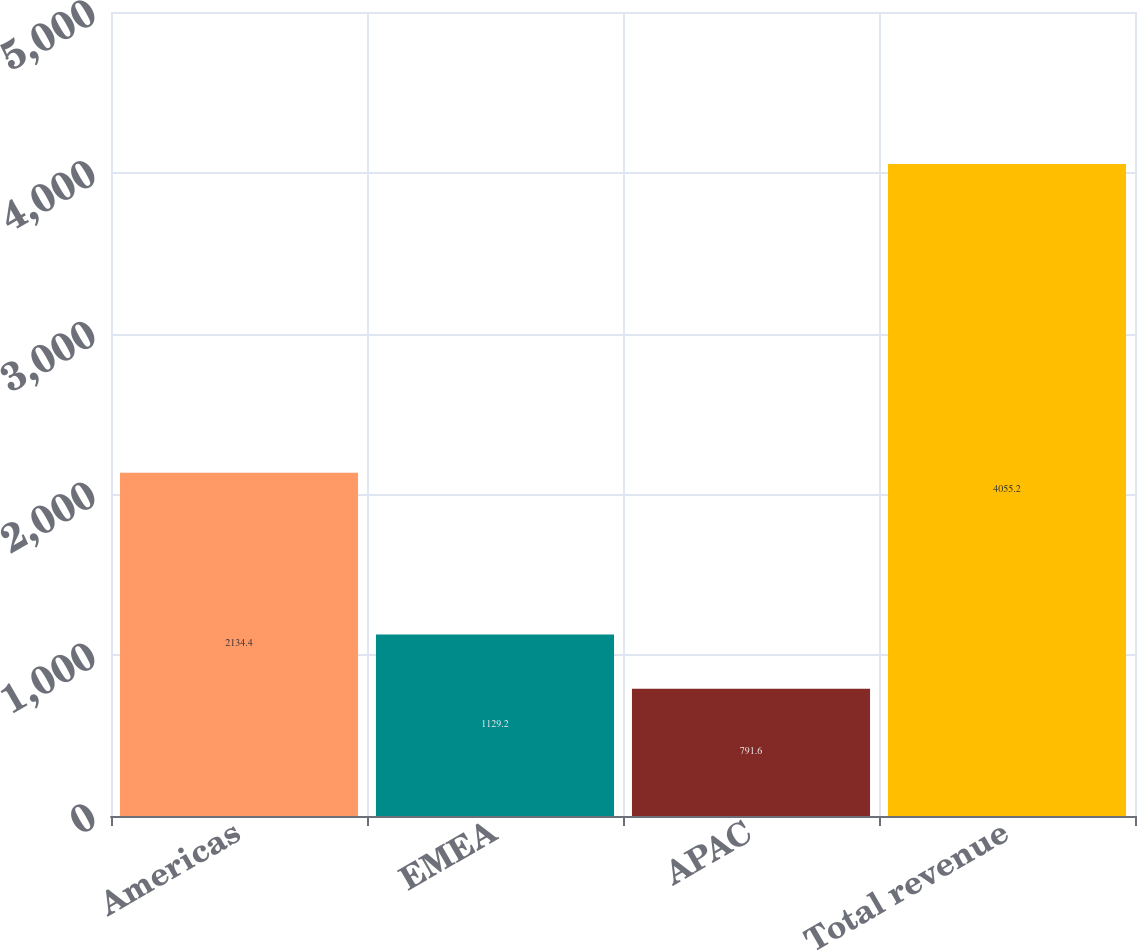<chart> <loc_0><loc_0><loc_500><loc_500><bar_chart><fcel>Americas<fcel>EMEA<fcel>APAC<fcel>Total revenue<nl><fcel>2134.4<fcel>1129.2<fcel>791.6<fcel>4055.2<nl></chart> 